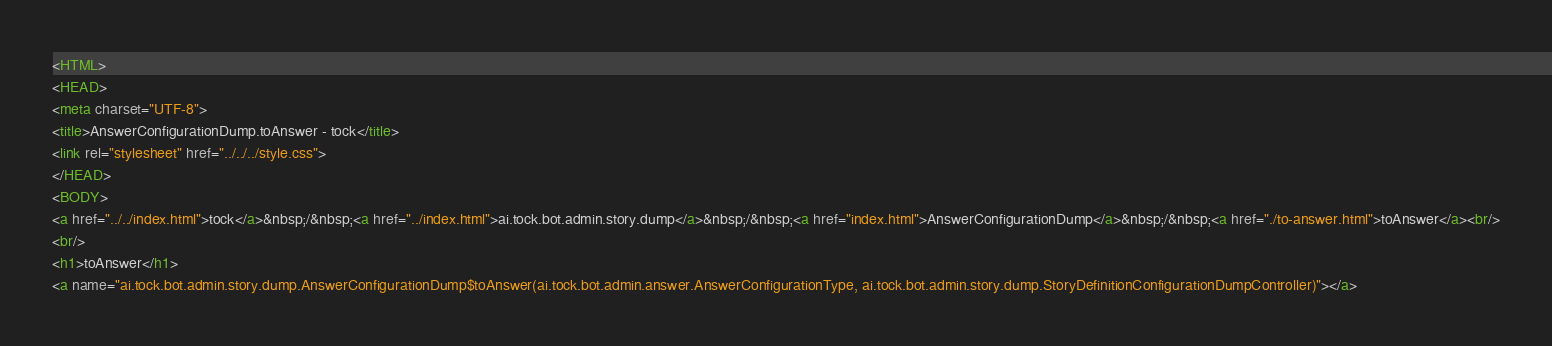Convert code to text. <code><loc_0><loc_0><loc_500><loc_500><_HTML_><HTML>
<HEAD>
<meta charset="UTF-8">
<title>AnswerConfigurationDump.toAnswer - tock</title>
<link rel="stylesheet" href="../../../style.css">
</HEAD>
<BODY>
<a href="../../index.html">tock</a>&nbsp;/&nbsp;<a href="../index.html">ai.tock.bot.admin.story.dump</a>&nbsp;/&nbsp;<a href="index.html">AnswerConfigurationDump</a>&nbsp;/&nbsp;<a href="./to-answer.html">toAnswer</a><br/>
<br/>
<h1>toAnswer</h1>
<a name="ai.tock.bot.admin.story.dump.AnswerConfigurationDump$toAnswer(ai.tock.bot.admin.answer.AnswerConfigurationType, ai.tock.bot.admin.story.dump.StoryDefinitionConfigurationDumpController)"></a></code> 